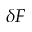<formula> <loc_0><loc_0><loc_500><loc_500>\delta F</formula> 